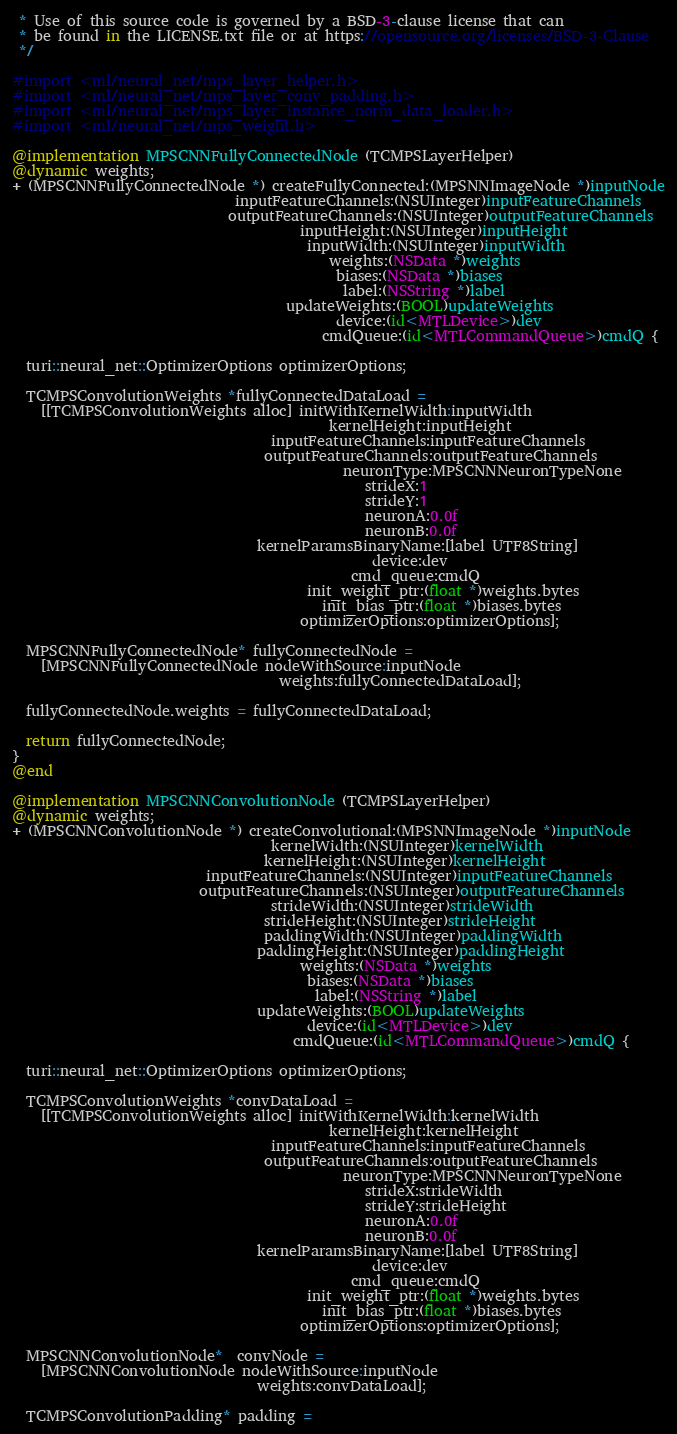<code> <loc_0><loc_0><loc_500><loc_500><_ObjectiveC_> * Use of this source code is governed by a BSD-3-clause license that can
 * be found in the LICENSE.txt file or at https://opensource.org/licenses/BSD-3-Clause
 */

#import <ml/neural_net/mps_layer_helper.h>
#import <ml/neural_net/mps_layer_conv_padding.h>
#import <ml/neural_net/mps_layer_instance_norm_data_loader.h>
#import <ml/neural_net/mps_weight.h>

@implementation MPSCNNFullyConnectedNode (TCMPSLayerHelper)
@dynamic weights;
+ (MPSCNNFullyConnectedNode *) createFullyConnected:(MPSNNImageNode *)inputNode
                               inputFeatureChannels:(NSUInteger)inputFeatureChannels
                              outputFeatureChannels:(NSUInteger)outputFeatureChannels
                                        inputHeight:(NSUInteger)inputHeight
                                         inputWidth:(NSUInteger)inputWidth
                                            weights:(NSData *)weights
                                             biases:(NSData *)biases
                                              label:(NSString *)label
                                      updateWeights:(BOOL)updateWeights
                                             device:(id<MTLDevice>)dev
                                           cmdQueue:(id<MTLCommandQueue>)cmdQ {
  
  turi::neural_net::OptimizerOptions optimizerOptions;

  TCMPSConvolutionWeights *fullyConnectedDataLoad =
    [[TCMPSConvolutionWeights alloc] initWithKernelWidth:inputWidth
                                            kernelHeight:inputHeight
                                    inputFeatureChannels:inputFeatureChannels
                                   outputFeatureChannels:outputFeatureChannels
                                              neuronType:MPSCNNNeuronTypeNone
                                                 strideX:1
                                                 strideY:1
                                                 neuronA:0.0f
                                                 neuronB:0.0f
                                  kernelParamsBinaryName:[label UTF8String]
                                                  device:dev
                                               cmd_queue:cmdQ
                                         init_weight_ptr:(float *)weights.bytes
                                           init_bias_ptr:(float *)biases.bytes
                                        optimizerOptions:optimizerOptions];
        
  MPSCNNFullyConnectedNode* fullyConnectedNode = 
    [MPSCNNFullyConnectedNode nodeWithSource:inputNode
                                     weights:fullyConnectedDataLoad];

  fullyConnectedNode.weights = fullyConnectedDataLoad;
  
  return fullyConnectedNode;
}
@end

@implementation MPSCNNConvolutionNode (TCMPSLayerHelper)
@dynamic weights;
+ (MPSCNNConvolutionNode *) createConvolutional:(MPSNNImageNode *)inputNode
                                    kernelWidth:(NSUInteger)kernelWidth
                                   kernelHeight:(NSUInteger)kernelHeight
                           inputFeatureChannels:(NSUInteger)inputFeatureChannels
                          outputFeatureChannels:(NSUInteger)outputFeatureChannels
                                    strideWidth:(NSUInteger)strideWidth
                                   strideHeight:(NSUInteger)strideHeight
                                   paddingWidth:(NSUInteger)paddingWidth
                                  paddingHeight:(NSUInteger)paddingHeight
                                        weights:(NSData *)weights
                                         biases:(NSData *)biases
                                          label:(NSString *)label
                                  updateWeights:(BOOL)updateWeights
                                         device:(id<MTLDevice>)dev
                                       cmdQueue:(id<MTLCommandQueue>)cmdQ {
  
  turi::neural_net::OptimizerOptions optimizerOptions;

  TCMPSConvolutionWeights *convDataLoad =
    [[TCMPSConvolutionWeights alloc] initWithKernelWidth:kernelWidth
                                            kernelHeight:kernelHeight
                                    inputFeatureChannels:inputFeatureChannels
                                   outputFeatureChannels:outputFeatureChannels
                                              neuronType:MPSCNNNeuronTypeNone
                                                 strideX:strideWidth
                                                 strideY:strideHeight
                                                 neuronA:0.0f
                                                 neuronB:0.0f
                                  kernelParamsBinaryName:[label UTF8String]
                                                  device:dev
                                               cmd_queue:cmdQ
                                         init_weight_ptr:(float *)weights.bytes
                                           init_bias_ptr:(float *)biases.bytes
                                        optimizerOptions:optimizerOptions];

  MPSCNNConvolutionNode*  convNode =
    [MPSCNNConvolutionNode nodeWithSource:inputNode
                                  weights:convDataLoad];

  TCMPSConvolutionPadding* padding = </code> 